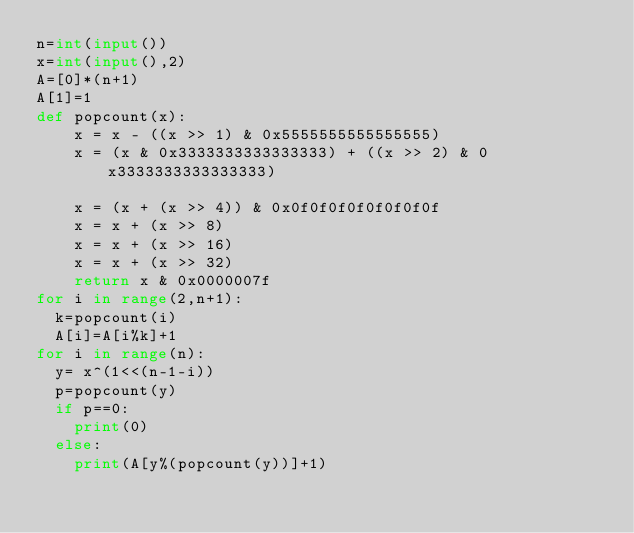Convert code to text. <code><loc_0><loc_0><loc_500><loc_500><_Python_>n=int(input())
x=int(input(),2)
A=[0]*(n+1)
A[1]=1
def popcount(x):
    x = x - ((x >> 1) & 0x5555555555555555)
    x = (x & 0x3333333333333333) + ((x >> 2) & 0x3333333333333333)

    x = (x + (x >> 4)) & 0x0f0f0f0f0f0f0f0f 
    x = x + (x >> 8) 
    x = x + (x >> 16)
    x = x + (x >> 32)
    return x & 0x0000007f
for i in range(2,n+1):
  k=popcount(i)
  A[i]=A[i%k]+1
for i in range(n):
  y= x^(1<<(n-1-i))
  p=popcount(y)
  if p==0:
    print(0)
  else:  
    print(A[y%(popcount(y))]+1)</code> 